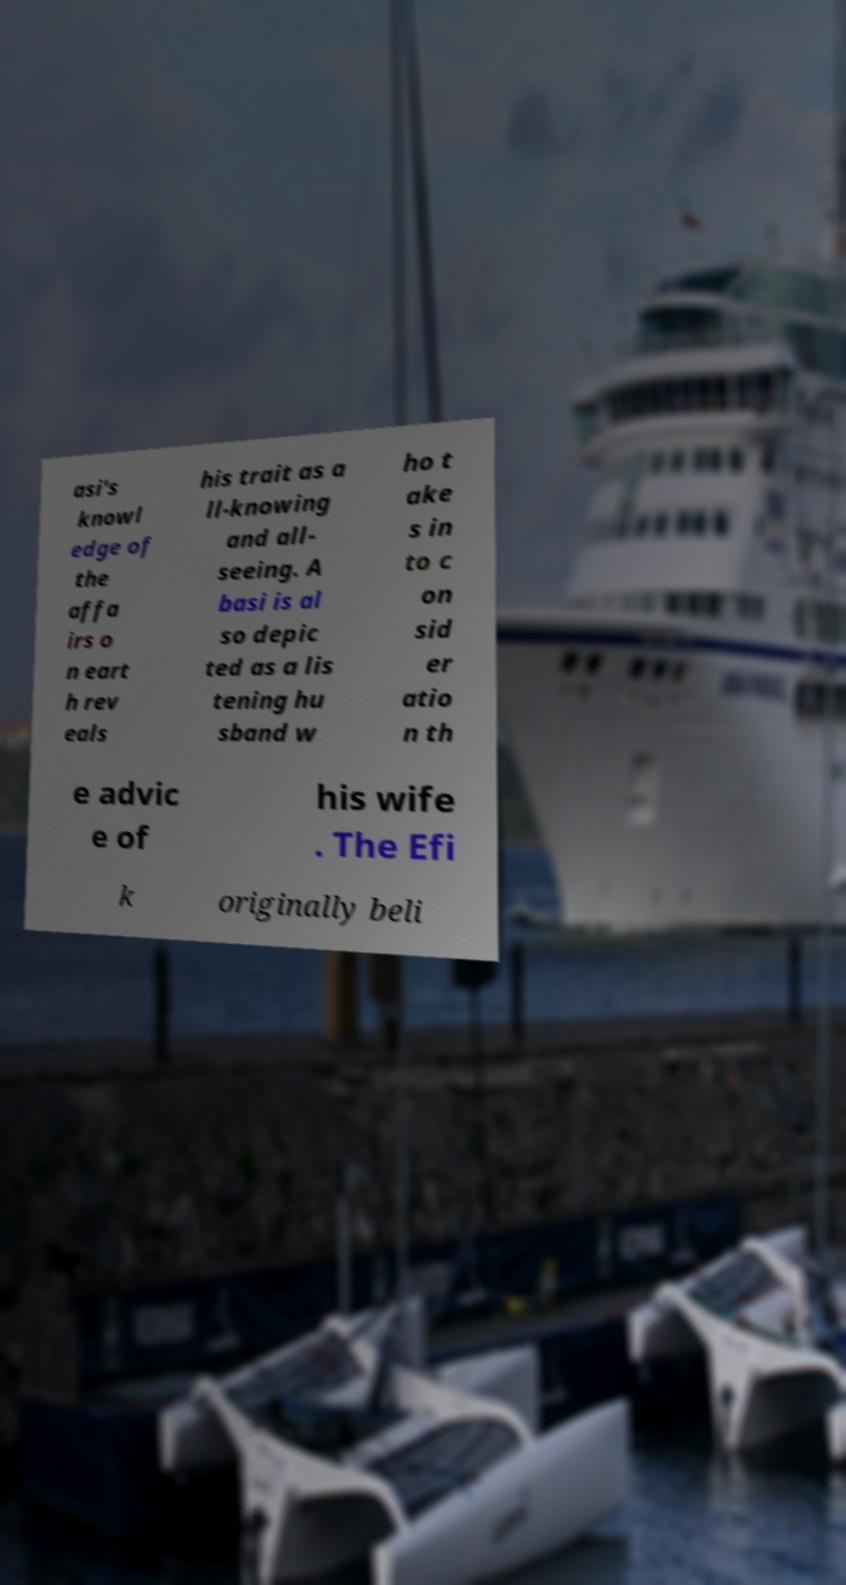Please read and relay the text visible in this image. What does it say? asi's knowl edge of the affa irs o n eart h rev eals his trait as a ll-knowing and all- seeing. A basi is al so depic ted as a lis tening hu sband w ho t ake s in to c on sid er atio n th e advic e of his wife . The Efi k originally beli 